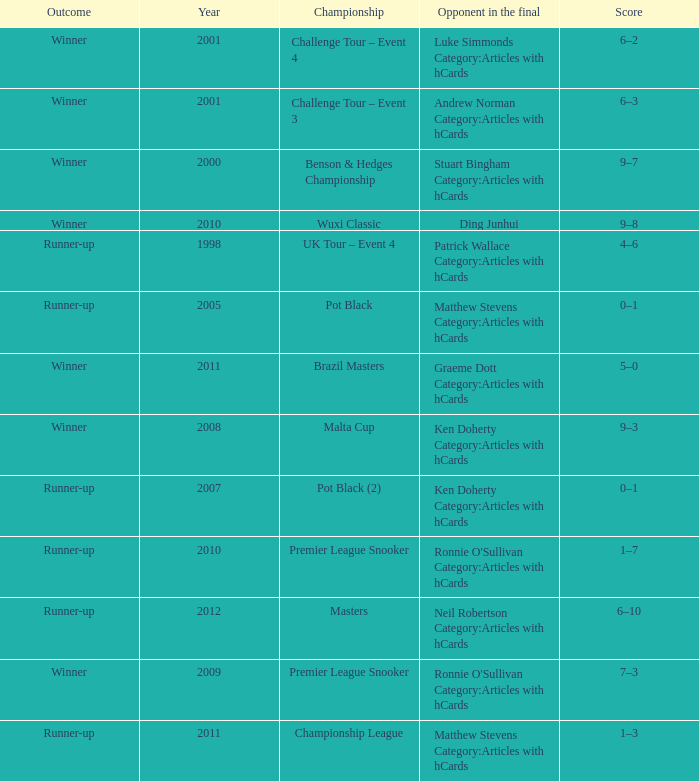What was Shaun Murphy's outcome in the Premier League Snooker championship held before 2010? Winner. Would you be able to parse every entry in this table? {'header': ['Outcome', 'Year', 'Championship', 'Opponent in the final', 'Score'], 'rows': [['Winner', '2001', 'Challenge Tour – Event 4', 'Luke Simmonds Category:Articles with hCards', '6–2'], ['Winner', '2001', 'Challenge Tour – Event 3', 'Andrew Norman Category:Articles with hCards', '6–3'], ['Winner', '2000', 'Benson & Hedges Championship', 'Stuart Bingham Category:Articles with hCards', '9–7'], ['Winner', '2010', 'Wuxi Classic', 'Ding Junhui', '9–8'], ['Runner-up', '1998', 'UK Tour – Event 4', 'Patrick Wallace Category:Articles with hCards', '4–6'], ['Runner-up', '2005', 'Pot Black', 'Matthew Stevens Category:Articles with hCards', '0–1'], ['Winner', '2011', 'Brazil Masters', 'Graeme Dott Category:Articles with hCards', '5–0'], ['Winner', '2008', 'Malta Cup', 'Ken Doherty Category:Articles with hCards', '9–3'], ['Runner-up', '2007', 'Pot Black (2)', 'Ken Doherty Category:Articles with hCards', '0–1'], ['Runner-up', '2010', 'Premier League Snooker', "Ronnie O'Sullivan Category:Articles with hCards", '1–7'], ['Runner-up', '2012', 'Masters', 'Neil Robertson Category:Articles with hCards', '6–10'], ['Winner', '2009', 'Premier League Snooker', "Ronnie O'Sullivan Category:Articles with hCards", '7–3'], ['Runner-up', '2011', 'Championship League', 'Matthew Stevens Category:Articles with hCards', '1–3']]} 